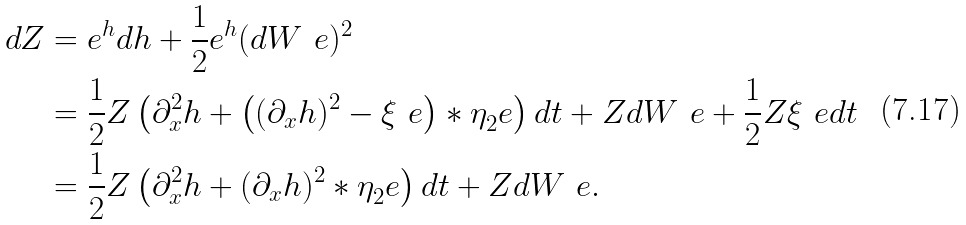Convert formula to latex. <formula><loc_0><loc_0><loc_500><loc_500>d Z & = e ^ { h } d h + \frac { 1 } { 2 } e ^ { h } ( d W ^ { \ } e ) ^ { 2 } \\ & = \frac { 1 } { 2 } Z \left ( \partial _ { x } ^ { 2 } h + \left ( ( \partial _ { x } h ) ^ { 2 } - \xi ^ { \ } e \right ) * \eta _ { 2 } ^ { \ } e \right ) d t + Z d W ^ { \ } e + \frac { 1 } { 2 } Z \xi ^ { \ } e d t \\ & = \frac { 1 } { 2 } Z \left ( \partial _ { x } ^ { 2 } h + ( \partial _ { x } h ) ^ { 2 } * \eta _ { 2 } ^ { \ } e \right ) d t + Z d W ^ { \ } e .</formula> 